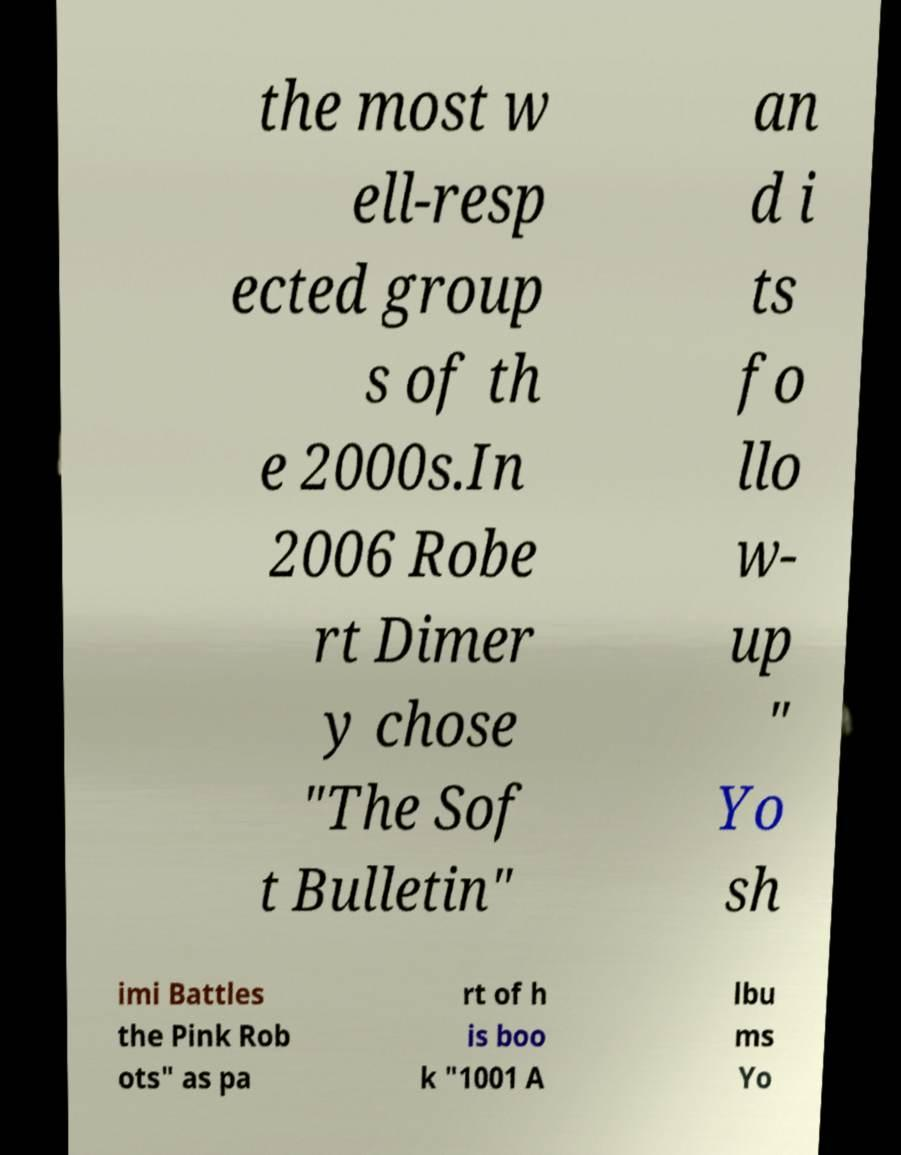What messages or text are displayed in this image? I need them in a readable, typed format. the most w ell-resp ected group s of th e 2000s.In 2006 Robe rt Dimer y chose "The Sof t Bulletin" an d i ts fo llo w- up " Yo sh imi Battles the Pink Rob ots" as pa rt of h is boo k "1001 A lbu ms Yo 